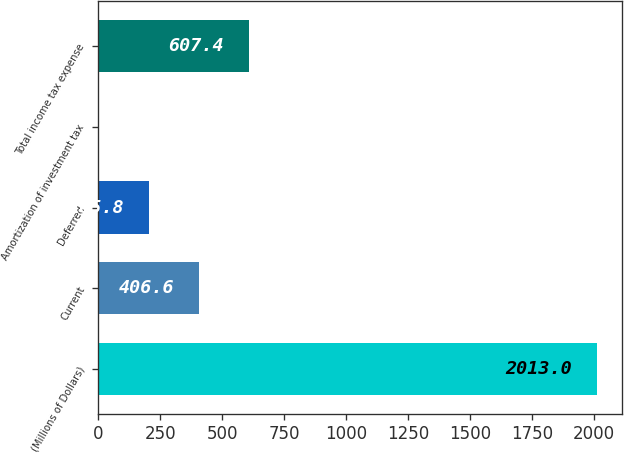Convert chart. <chart><loc_0><loc_0><loc_500><loc_500><bar_chart><fcel>(Millions of Dollars)<fcel>Current<fcel>Deferred<fcel>Amortization of investment tax<fcel>Total income tax expense<nl><fcel>2013<fcel>406.6<fcel>205.8<fcel>5<fcel>607.4<nl></chart> 